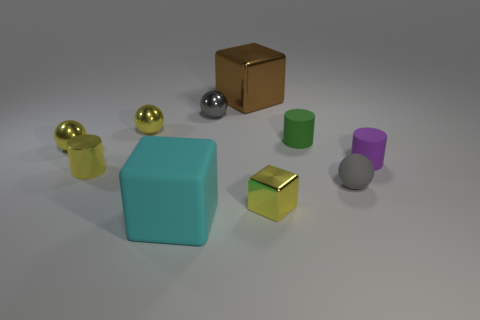Subtract 1 spheres. How many spheres are left? 3 Subtract all cylinders. How many objects are left? 7 Add 7 small cyan cubes. How many small cyan cubes exist? 7 Subtract 0 blue spheres. How many objects are left? 10 Subtract all cylinders. Subtract all small yellow metallic objects. How many objects are left? 3 Add 7 small yellow shiny cylinders. How many small yellow shiny cylinders are left? 8 